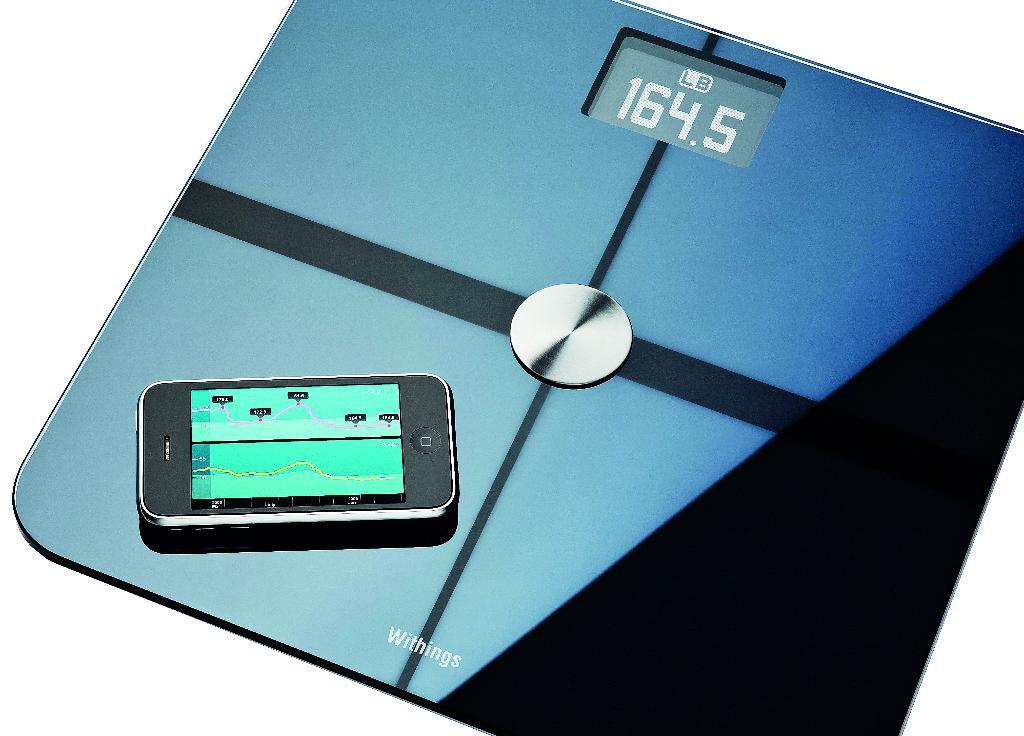How much does the phone weigh?
Offer a very short reply. 164.5. 